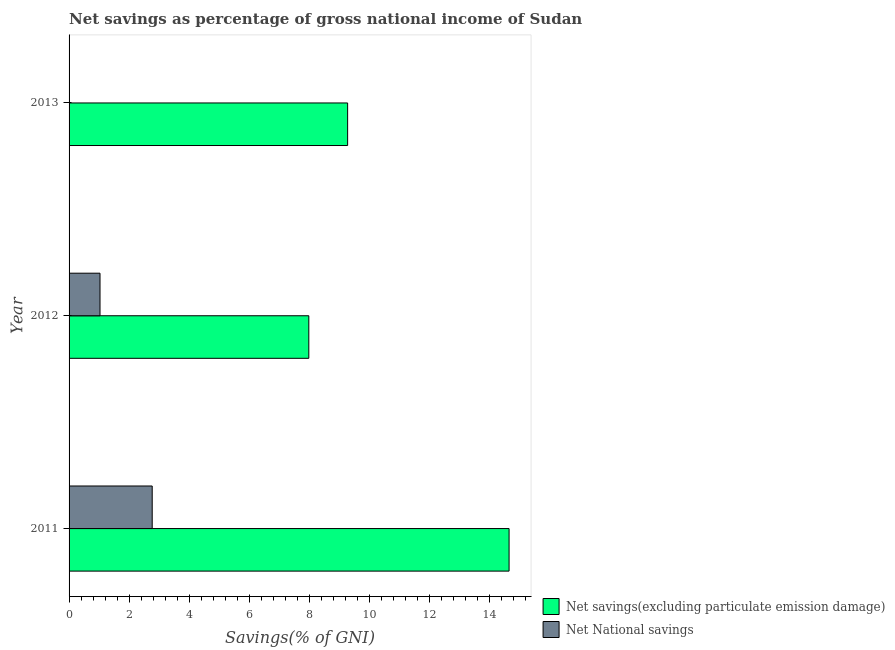How many different coloured bars are there?
Provide a succinct answer. 2. Are the number of bars per tick equal to the number of legend labels?
Give a very brief answer. No. Are the number of bars on each tick of the Y-axis equal?
Ensure brevity in your answer.  No. How many bars are there on the 3rd tick from the top?
Offer a terse response. 2. In how many cases, is the number of bars for a given year not equal to the number of legend labels?
Provide a succinct answer. 1. What is the net savings(excluding particulate emission damage) in 2012?
Give a very brief answer. 7.99. Across all years, what is the maximum net savings(excluding particulate emission damage)?
Provide a short and direct response. 14.66. Across all years, what is the minimum net savings(excluding particulate emission damage)?
Provide a succinct answer. 7.99. What is the total net national savings in the graph?
Your response must be concise. 3.8. What is the difference between the net savings(excluding particulate emission damage) in 2012 and that in 2013?
Give a very brief answer. -1.29. What is the difference between the net national savings in 2011 and the net savings(excluding particulate emission damage) in 2013?
Your answer should be very brief. -6.51. What is the average net savings(excluding particulate emission damage) per year?
Provide a short and direct response. 10.65. In the year 2011, what is the difference between the net national savings and net savings(excluding particulate emission damage)?
Your response must be concise. -11.89. In how many years, is the net savings(excluding particulate emission damage) greater than 0.8 %?
Your answer should be very brief. 3. What is the ratio of the net savings(excluding particulate emission damage) in 2011 to that in 2013?
Your answer should be compact. 1.58. Is the difference between the net savings(excluding particulate emission damage) in 2011 and 2012 greater than the difference between the net national savings in 2011 and 2012?
Provide a succinct answer. Yes. What is the difference between the highest and the second highest net savings(excluding particulate emission damage)?
Your response must be concise. 5.38. What is the difference between the highest and the lowest net national savings?
Provide a succinct answer. 2.77. Is the sum of the net savings(excluding particulate emission damage) in 2012 and 2013 greater than the maximum net national savings across all years?
Offer a very short reply. Yes. How many bars are there?
Keep it short and to the point. 5. Does the graph contain any zero values?
Give a very brief answer. Yes. Where does the legend appear in the graph?
Your answer should be compact. Bottom right. What is the title of the graph?
Your response must be concise. Net savings as percentage of gross national income of Sudan. What is the label or title of the X-axis?
Ensure brevity in your answer.  Savings(% of GNI). What is the Savings(% of GNI) in Net savings(excluding particulate emission damage) in 2011?
Keep it short and to the point. 14.66. What is the Savings(% of GNI) in Net National savings in 2011?
Keep it short and to the point. 2.77. What is the Savings(% of GNI) in Net savings(excluding particulate emission damage) in 2012?
Offer a very short reply. 7.99. What is the Savings(% of GNI) in Net National savings in 2012?
Your response must be concise. 1.03. What is the Savings(% of GNI) of Net savings(excluding particulate emission damage) in 2013?
Give a very brief answer. 9.28. What is the Savings(% of GNI) of Net National savings in 2013?
Make the answer very short. 0. Across all years, what is the maximum Savings(% of GNI) of Net savings(excluding particulate emission damage)?
Offer a terse response. 14.66. Across all years, what is the maximum Savings(% of GNI) in Net National savings?
Keep it short and to the point. 2.77. Across all years, what is the minimum Savings(% of GNI) of Net savings(excluding particulate emission damage)?
Provide a short and direct response. 7.99. What is the total Savings(% of GNI) of Net savings(excluding particulate emission damage) in the graph?
Your answer should be compact. 31.94. What is the total Savings(% of GNI) of Net National savings in the graph?
Provide a succinct answer. 3.8. What is the difference between the Savings(% of GNI) of Net savings(excluding particulate emission damage) in 2011 and that in 2012?
Provide a succinct answer. 6.67. What is the difference between the Savings(% of GNI) of Net National savings in 2011 and that in 2012?
Your answer should be very brief. 1.74. What is the difference between the Savings(% of GNI) of Net savings(excluding particulate emission damage) in 2011 and that in 2013?
Ensure brevity in your answer.  5.38. What is the difference between the Savings(% of GNI) of Net savings(excluding particulate emission damage) in 2012 and that in 2013?
Offer a very short reply. -1.29. What is the difference between the Savings(% of GNI) of Net savings(excluding particulate emission damage) in 2011 and the Savings(% of GNI) of Net National savings in 2012?
Offer a very short reply. 13.63. What is the average Savings(% of GNI) in Net savings(excluding particulate emission damage) per year?
Provide a short and direct response. 10.65. What is the average Savings(% of GNI) in Net National savings per year?
Your answer should be compact. 1.27. In the year 2011, what is the difference between the Savings(% of GNI) of Net savings(excluding particulate emission damage) and Savings(% of GNI) of Net National savings?
Your answer should be compact. 11.89. In the year 2012, what is the difference between the Savings(% of GNI) of Net savings(excluding particulate emission damage) and Savings(% of GNI) of Net National savings?
Give a very brief answer. 6.96. What is the ratio of the Savings(% of GNI) in Net savings(excluding particulate emission damage) in 2011 to that in 2012?
Keep it short and to the point. 1.84. What is the ratio of the Savings(% of GNI) of Net National savings in 2011 to that in 2012?
Offer a very short reply. 2.69. What is the ratio of the Savings(% of GNI) of Net savings(excluding particulate emission damage) in 2011 to that in 2013?
Your response must be concise. 1.58. What is the ratio of the Savings(% of GNI) in Net savings(excluding particulate emission damage) in 2012 to that in 2013?
Ensure brevity in your answer.  0.86. What is the difference between the highest and the second highest Savings(% of GNI) of Net savings(excluding particulate emission damage)?
Make the answer very short. 5.38. What is the difference between the highest and the lowest Savings(% of GNI) in Net savings(excluding particulate emission damage)?
Provide a succinct answer. 6.67. What is the difference between the highest and the lowest Savings(% of GNI) of Net National savings?
Provide a short and direct response. 2.77. 